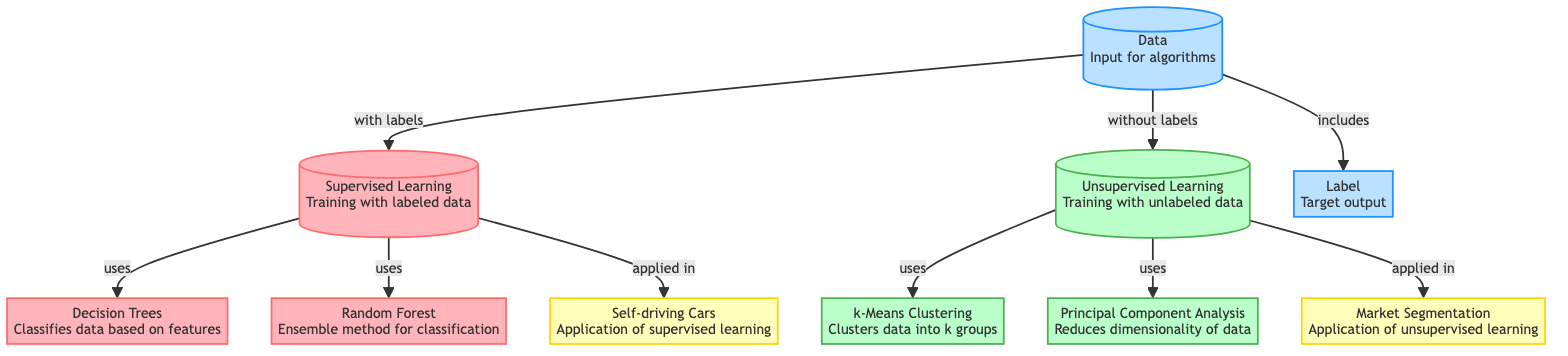What type of data does supervised learning use? Supervised learning uses labeled data for training. This can be identified from the diagram where the node for supervised learning is connected to another node labeled "Data" with the label "with labels."
Answer: labeled data What is the application of unsupervised learning shown in the diagram? The application of unsupervised learning in the diagram is represented by the node that states "Market Segmentation." This is linked to the unsupervised learning node, indicating a practical use case.
Answer: Market Segmentation How many algorithms are mentioned under supervised learning? Two algorithms are listed under supervised learning: Decision Trees and Random Forest, which connect directly to the supervised learning node. Therefore, counting these nodes provides the answer.
Answer: 2 Which clustering method is used in unsupervised learning? The clustering method used in unsupervised learning is k-Means Clustering. This is explicitly stated in the diagram, indicating that it is an algorithm utilized in that category.
Answer: k-Means Clustering What connects the "Data" node to "Supervised Learning"? The label connecting the "Data" node to "Supervised Learning" states "with labels." This indicates the type of data required for the supervised learning approach.
Answer: with labels How does supervised learning apply to self-driving cars? The connection is direct: the diagram shows a link from supervised learning to the application node stating "Self-driving Cars," indicating that supervised learning techniques are used in this context.
Answer: Self-driving Cars What is the purpose of Principal Component Analysis in unsupervised learning? Principal Component Analysis is for reducing dimensionality of data, as specified in its respective node. This indicates its role within unsupervised learning.
Answer: Reduces dimensionality What is the relationship between unsupervised learning and labeled data? Unsupervised learning uses unlabeled data, as indicated in the diagram, which connects unsupervised learning to the node "Data" with the label "without labels."
Answer: unlabeled data Which learning technique applies to both algorithms listed under supervised learning? Supervised learning applies to both algorithms mentioned: Decision Trees and Random Forest. This is clear from the connections indicated in the diagram from the supervised learning node to these algorithms.
Answer: Supervised Learning 